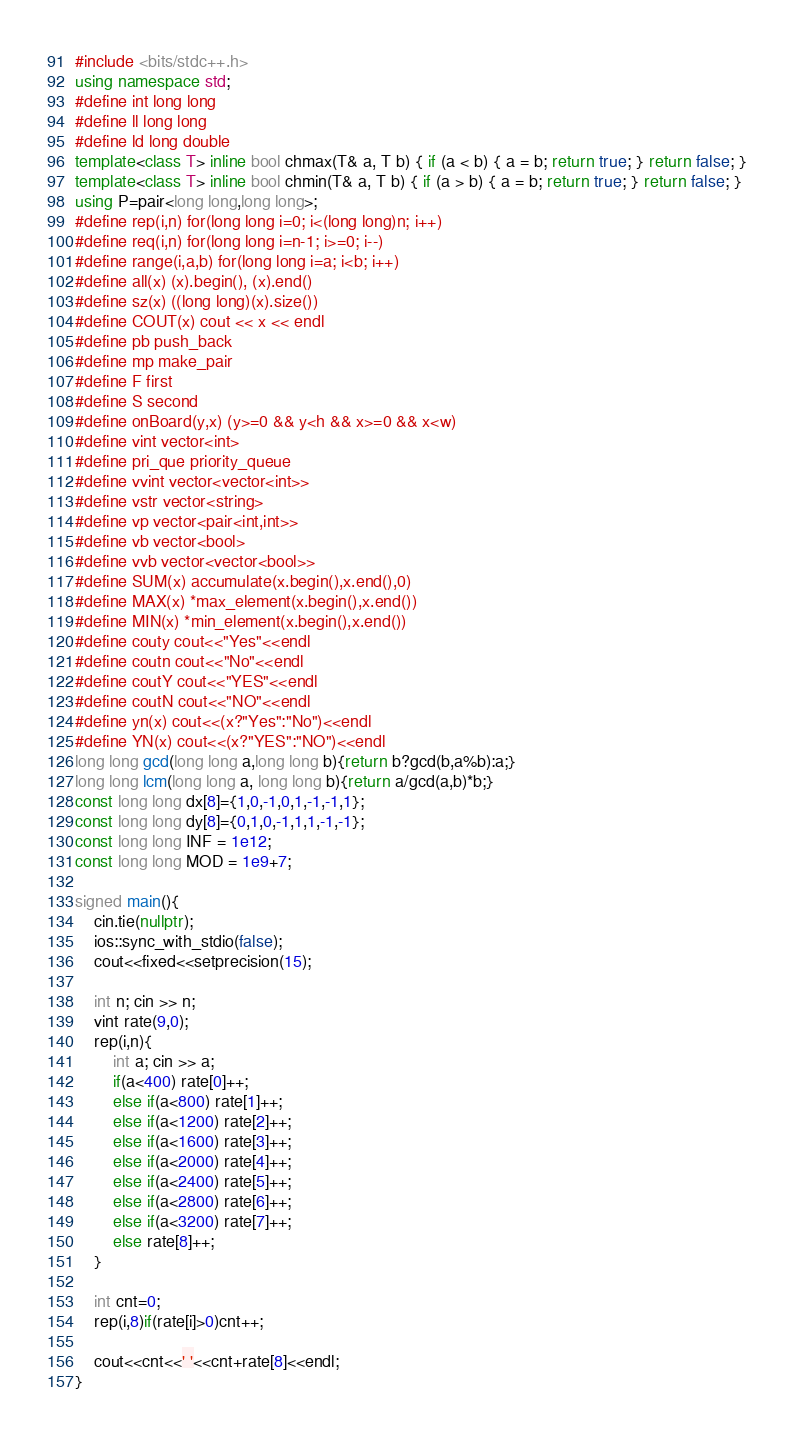Convert code to text. <code><loc_0><loc_0><loc_500><loc_500><_C++_>#include <bits/stdc++.h>
using namespace std;
#define int long long
#define ll long long
#define ld long double
template<class T> inline bool chmax(T& a, T b) { if (a < b) { a = b; return true; } return false; }
template<class T> inline bool chmin(T& a, T b) { if (a > b) { a = b; return true; } return false; }
using P=pair<long long,long long>;
#define rep(i,n) for(long long i=0; i<(long long)n; i++)
#define req(i,n) for(long long i=n-1; i>=0; i--)
#define range(i,a,b) for(long long i=a; i<b; i++)
#define all(x) (x).begin(), (x).end()
#define sz(x) ((long long)(x).size())
#define COUT(x) cout << x << endl
#define pb push_back
#define mp make_pair
#define F first
#define S second
#define onBoard(y,x) (y>=0 && y<h && x>=0 && x<w)
#define vint vector<int>
#define pri_que priority_queue
#define vvint vector<vector<int>>
#define vstr vector<string>
#define vp vector<pair<int,int>>
#define vb vector<bool>
#define vvb vector<vector<bool>>
#define SUM(x) accumulate(x.begin(),x.end(),0)
#define MAX(x) *max_element(x.begin(),x.end())
#define MIN(x) *min_element(x.begin(),x.end())
#define couty cout<<"Yes"<<endl
#define coutn cout<<"No"<<endl
#define coutY cout<<"YES"<<endl
#define coutN cout<<"NO"<<endl
#define yn(x) cout<<(x?"Yes":"No")<<endl
#define YN(x) cout<<(x?"YES":"NO")<<endl
long long gcd(long long a,long long b){return b?gcd(b,a%b):a;}
long long lcm(long long a, long long b){return a/gcd(a,b)*b;}
const long long dx[8]={1,0,-1,0,1,-1,-1,1};
const long long dy[8]={0,1,0,-1,1,1,-1,-1};
const long long INF = 1e12;
const long long MOD = 1e9+7;

signed main(){
    cin.tie(nullptr);
    ios::sync_with_stdio(false);
    cout<<fixed<<setprecision(15);

    int n; cin >> n;
    vint rate(9,0);
    rep(i,n){
        int a; cin >> a;
        if(a<400) rate[0]++;
        else if(a<800) rate[1]++;
        else if(a<1200) rate[2]++;
        else if(a<1600) rate[3]++;
        else if(a<2000) rate[4]++;
        else if(a<2400) rate[5]++;
        else if(a<2800) rate[6]++;
        else if(a<3200) rate[7]++;
        else rate[8]++;
    }
    
    int cnt=0;
    rep(i,8)if(rate[i]>0)cnt++;
    
    cout<<cnt<<' '<<cnt+rate[8]<<endl;
}</code> 